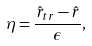Convert formula to latex. <formula><loc_0><loc_0><loc_500><loc_500>\eta = \frac { \hat { r } _ { t r } - \hat { r } } { \epsilon } ,</formula> 